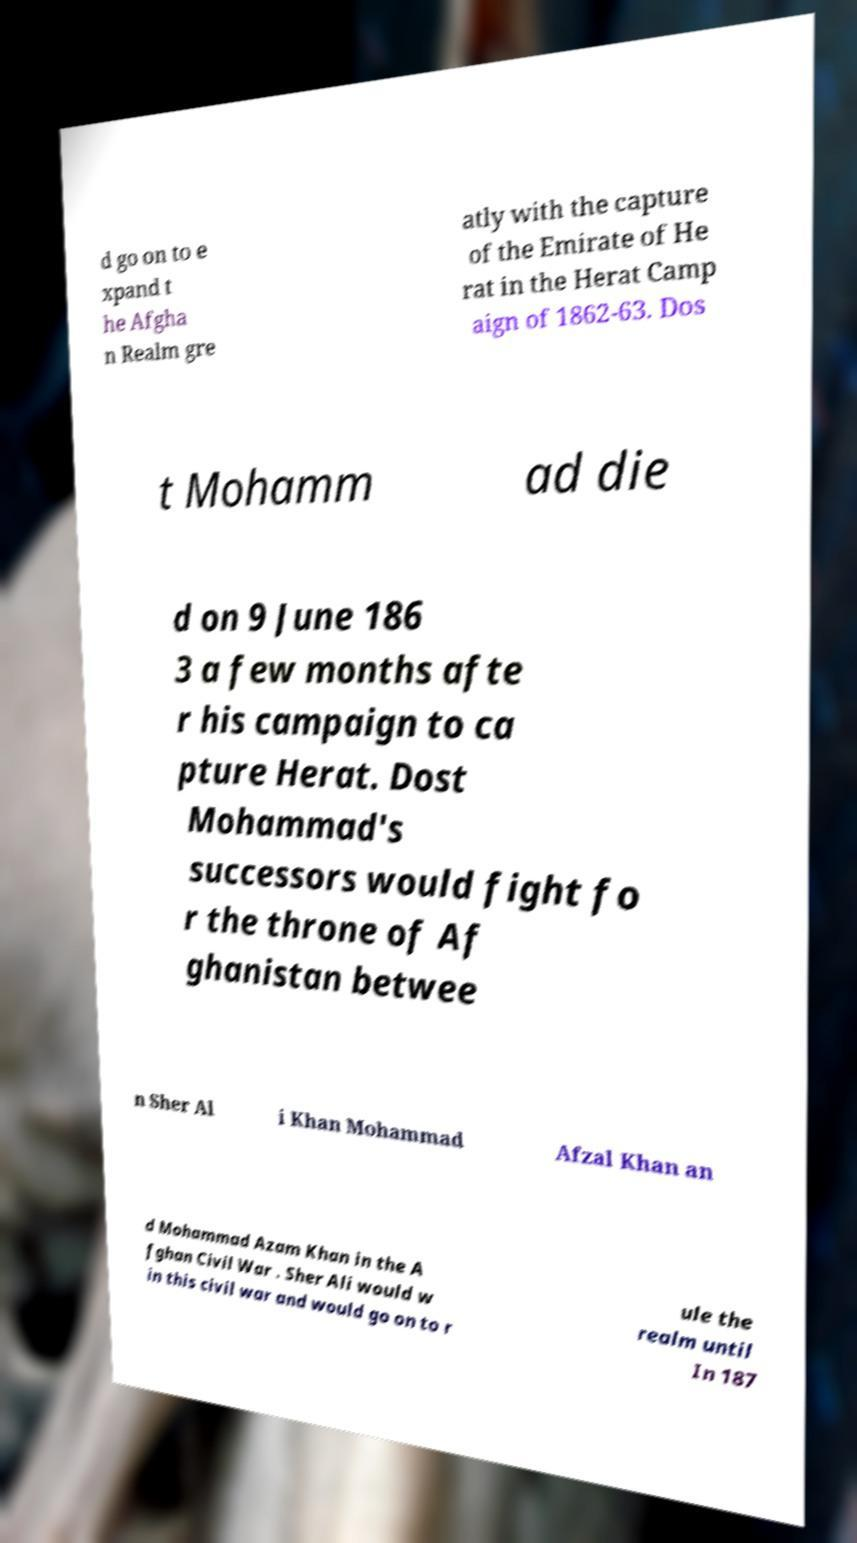Please read and relay the text visible in this image. What does it say? d go on to e xpand t he Afgha n Realm gre atly with the capture of the Emirate of He rat in the Herat Camp aign of 1862-63. Dos t Mohamm ad die d on 9 June 186 3 a few months afte r his campaign to ca pture Herat. Dost Mohammad's successors would fight fo r the throne of Af ghanistan betwee n Sher Al i Khan Mohammad Afzal Khan an d Mohammad Azam Khan in the A fghan Civil War . Sher Ali would w in this civil war and would go on to r ule the realm until In 187 